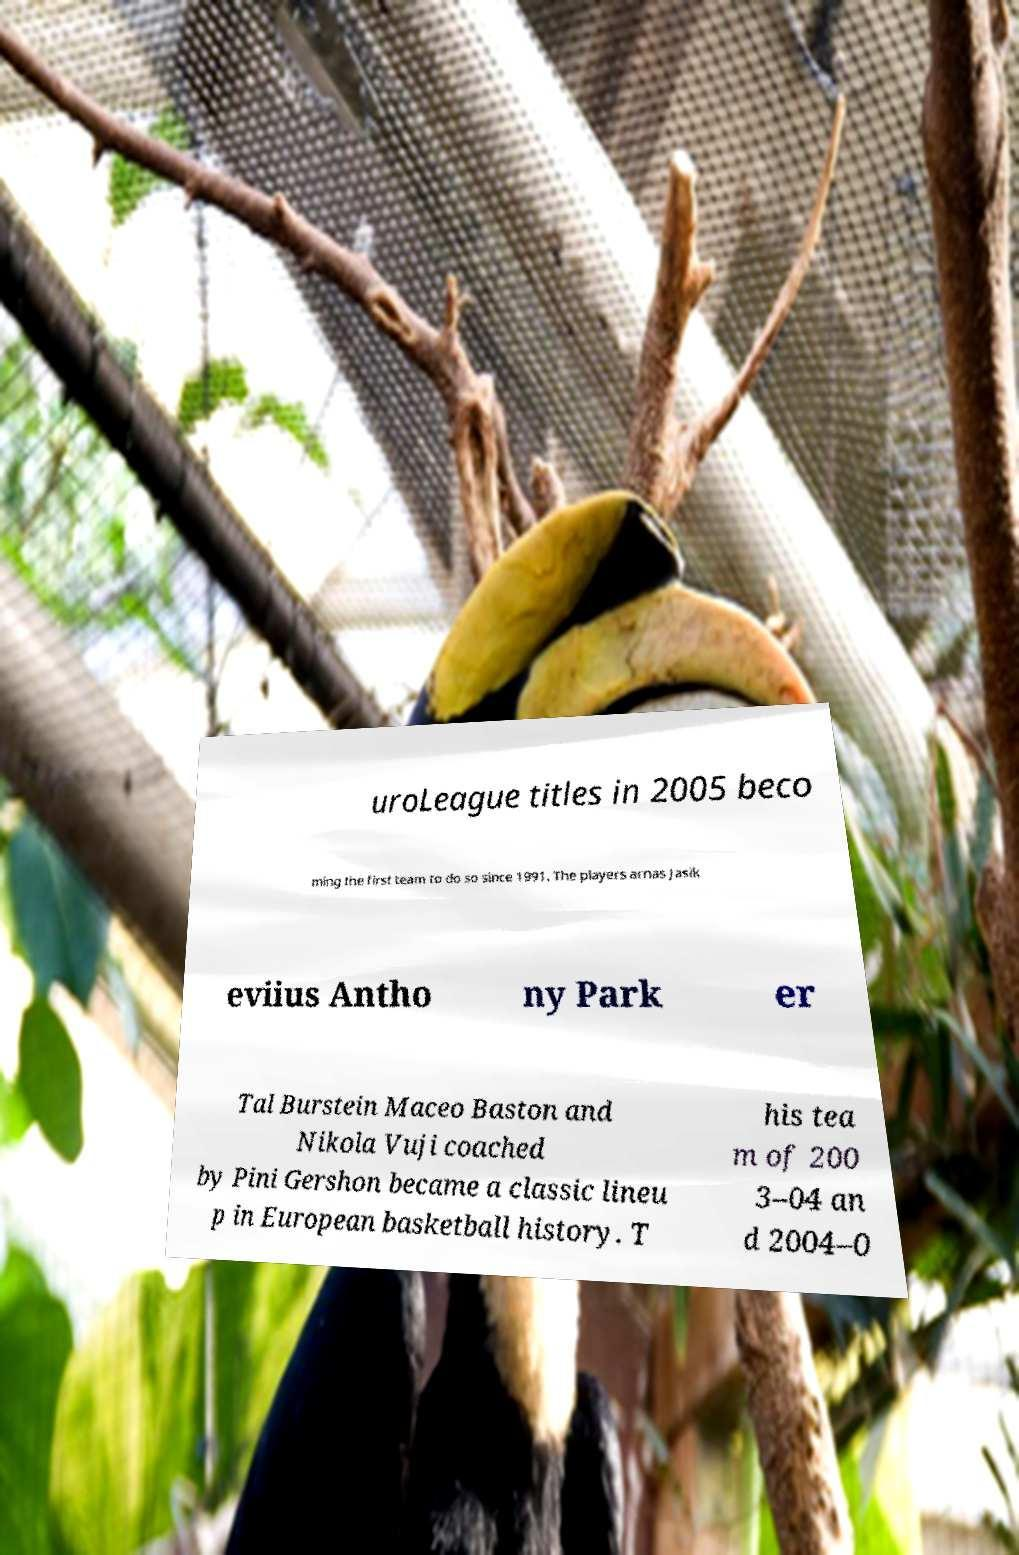Please identify and transcribe the text found in this image. uroLeague titles in 2005 beco ming the first team to do so since 1991. The players arnas Jasik eviius Antho ny Park er Tal Burstein Maceo Baston and Nikola Vuji coached by Pini Gershon became a classic lineu p in European basketball history. T his tea m of 200 3–04 an d 2004–0 